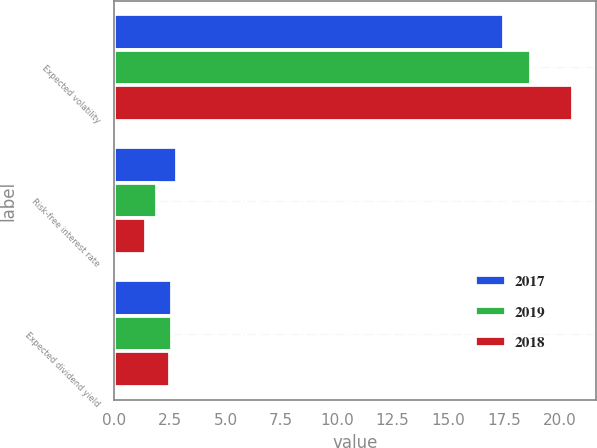Convert chart. <chart><loc_0><loc_0><loc_500><loc_500><stacked_bar_chart><ecel><fcel>Expected volatility<fcel>Risk-free interest rate<fcel>Expected dividend yield<nl><fcel>2017<fcel>17.5<fcel>2.8<fcel>2.6<nl><fcel>2019<fcel>18.7<fcel>1.9<fcel>2.6<nl><fcel>2018<fcel>20.6<fcel>1.4<fcel>2.5<nl></chart> 